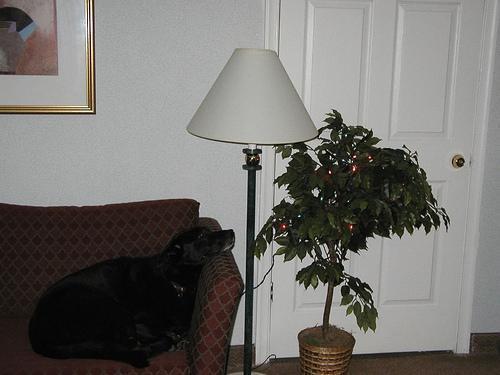How many people are pictured sitting down?
Give a very brief answer. 0. 